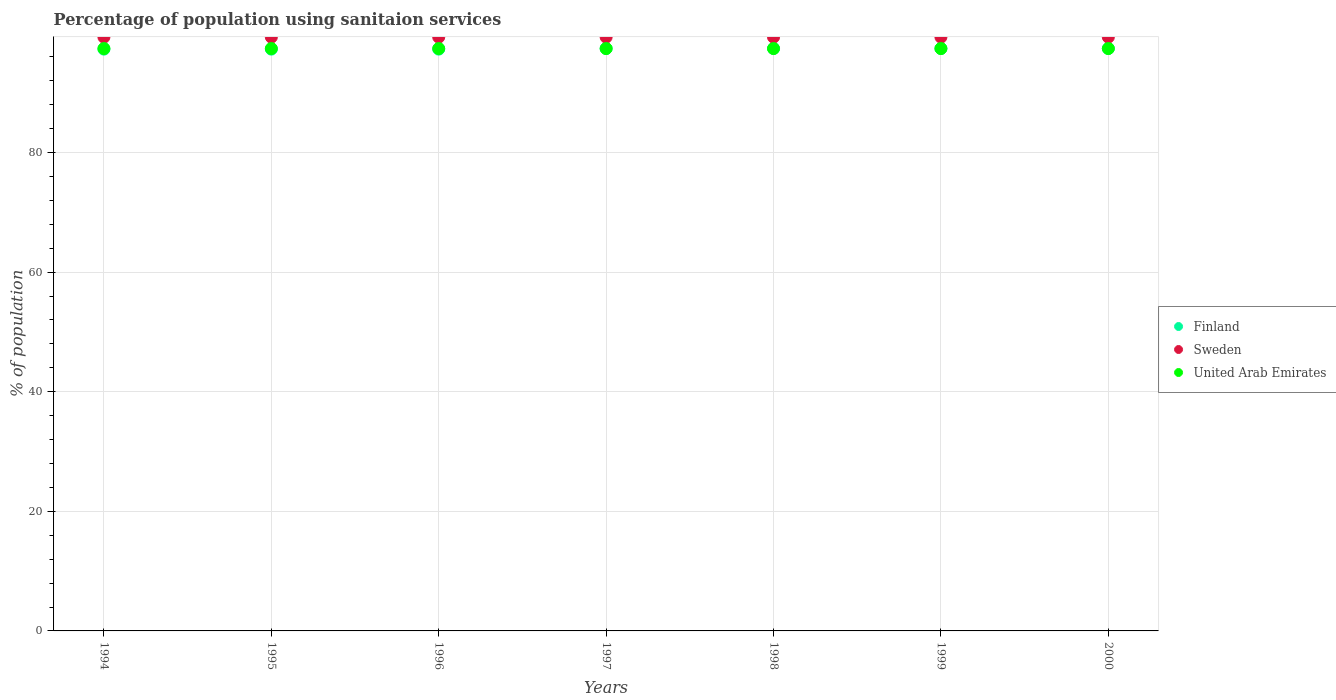Is the number of dotlines equal to the number of legend labels?
Ensure brevity in your answer.  Yes. What is the percentage of population using sanitaion services in Sweden in 1994?
Offer a very short reply. 99.3. Across all years, what is the maximum percentage of population using sanitaion services in United Arab Emirates?
Make the answer very short. 97.4. Across all years, what is the minimum percentage of population using sanitaion services in Finland?
Your response must be concise. 97.3. In which year was the percentage of population using sanitaion services in Sweden maximum?
Your answer should be very brief. 1994. In which year was the percentage of population using sanitaion services in Finland minimum?
Provide a short and direct response. 1994. What is the total percentage of population using sanitaion services in Sweden in the graph?
Your answer should be compact. 695.1. What is the difference between the percentage of population using sanitaion services in United Arab Emirates in 1995 and that in 1999?
Your answer should be compact. 0. What is the difference between the percentage of population using sanitaion services in Sweden in 1995 and the percentage of population using sanitaion services in United Arab Emirates in 1997?
Provide a short and direct response. 1.9. What is the average percentage of population using sanitaion services in United Arab Emirates per year?
Your response must be concise. 97.4. In the year 1997, what is the difference between the percentage of population using sanitaion services in Finland and percentage of population using sanitaion services in Sweden?
Keep it short and to the point. -1.9. In how many years, is the percentage of population using sanitaion services in Finland greater than 32 %?
Your answer should be compact. 7. What is the difference between the highest and the lowest percentage of population using sanitaion services in United Arab Emirates?
Make the answer very short. 0. Is it the case that in every year, the sum of the percentage of population using sanitaion services in Finland and percentage of population using sanitaion services in Sweden  is greater than the percentage of population using sanitaion services in United Arab Emirates?
Provide a succinct answer. Yes. Does the percentage of population using sanitaion services in Finland monotonically increase over the years?
Make the answer very short. No. Is the percentage of population using sanitaion services in Sweden strictly less than the percentage of population using sanitaion services in Finland over the years?
Offer a terse response. No. How many dotlines are there?
Offer a terse response. 3. How many years are there in the graph?
Your answer should be compact. 7. What is the difference between two consecutive major ticks on the Y-axis?
Ensure brevity in your answer.  20. Does the graph contain any zero values?
Give a very brief answer. No. Does the graph contain grids?
Your answer should be very brief. Yes. How are the legend labels stacked?
Provide a succinct answer. Vertical. What is the title of the graph?
Your answer should be very brief. Percentage of population using sanitaion services. Does "Seychelles" appear as one of the legend labels in the graph?
Ensure brevity in your answer.  No. What is the label or title of the X-axis?
Your answer should be compact. Years. What is the label or title of the Y-axis?
Make the answer very short. % of population. What is the % of population of Finland in 1994?
Offer a very short reply. 97.3. What is the % of population of Sweden in 1994?
Provide a succinct answer. 99.3. What is the % of population of United Arab Emirates in 1994?
Your response must be concise. 97.4. What is the % of population in Finland in 1995?
Provide a short and direct response. 97.3. What is the % of population of Sweden in 1995?
Give a very brief answer. 99.3. What is the % of population of United Arab Emirates in 1995?
Provide a short and direct response. 97.4. What is the % of population in Finland in 1996?
Make the answer very short. 97.3. What is the % of population of Sweden in 1996?
Provide a short and direct response. 99.3. What is the % of population of United Arab Emirates in 1996?
Your response must be concise. 97.4. What is the % of population of Finland in 1997?
Keep it short and to the point. 97.4. What is the % of population of Sweden in 1997?
Provide a short and direct response. 99.3. What is the % of population in United Arab Emirates in 1997?
Your answer should be very brief. 97.4. What is the % of population of Finland in 1998?
Provide a short and direct response. 97.4. What is the % of population of Sweden in 1998?
Ensure brevity in your answer.  99.3. What is the % of population of United Arab Emirates in 1998?
Your answer should be compact. 97.4. What is the % of population in Finland in 1999?
Give a very brief answer. 97.4. What is the % of population of Sweden in 1999?
Make the answer very short. 99.3. What is the % of population of United Arab Emirates in 1999?
Provide a succinct answer. 97.4. What is the % of population in Finland in 2000?
Ensure brevity in your answer.  97.4. What is the % of population of Sweden in 2000?
Keep it short and to the point. 99.3. What is the % of population of United Arab Emirates in 2000?
Your answer should be compact. 97.4. Across all years, what is the maximum % of population in Finland?
Your response must be concise. 97.4. Across all years, what is the maximum % of population in Sweden?
Offer a very short reply. 99.3. Across all years, what is the maximum % of population in United Arab Emirates?
Provide a succinct answer. 97.4. Across all years, what is the minimum % of population of Finland?
Your answer should be compact. 97.3. Across all years, what is the minimum % of population of Sweden?
Ensure brevity in your answer.  99.3. Across all years, what is the minimum % of population in United Arab Emirates?
Offer a very short reply. 97.4. What is the total % of population of Finland in the graph?
Give a very brief answer. 681.5. What is the total % of population in Sweden in the graph?
Your answer should be compact. 695.1. What is the total % of population in United Arab Emirates in the graph?
Your answer should be very brief. 681.8. What is the difference between the % of population of Sweden in 1994 and that in 1995?
Keep it short and to the point. 0. What is the difference between the % of population of Finland in 1994 and that in 1996?
Offer a terse response. 0. What is the difference between the % of population in United Arab Emirates in 1994 and that in 1996?
Make the answer very short. 0. What is the difference between the % of population of Sweden in 1994 and that in 1997?
Ensure brevity in your answer.  0. What is the difference between the % of population of United Arab Emirates in 1994 and that in 1997?
Your answer should be very brief. 0. What is the difference between the % of population of Finland in 1994 and that in 1998?
Offer a terse response. -0.1. What is the difference between the % of population in United Arab Emirates in 1994 and that in 1998?
Your answer should be compact. 0. What is the difference between the % of population of Finland in 1994 and that in 1999?
Provide a succinct answer. -0.1. What is the difference between the % of population in Sweden in 1994 and that in 1999?
Offer a very short reply. 0. What is the difference between the % of population of United Arab Emirates in 1994 and that in 1999?
Provide a short and direct response. 0. What is the difference between the % of population of Finland in 1994 and that in 2000?
Provide a short and direct response. -0.1. What is the difference between the % of population of Finland in 1995 and that in 1996?
Make the answer very short. 0. What is the difference between the % of population of United Arab Emirates in 1995 and that in 1996?
Ensure brevity in your answer.  0. What is the difference between the % of population in Finland in 1995 and that in 1997?
Offer a very short reply. -0.1. What is the difference between the % of population of Sweden in 1995 and that in 1998?
Provide a succinct answer. 0. What is the difference between the % of population of Sweden in 1995 and that in 1999?
Give a very brief answer. 0. What is the difference between the % of population of Finland in 1995 and that in 2000?
Your answer should be very brief. -0.1. What is the difference between the % of population of Sweden in 1995 and that in 2000?
Provide a short and direct response. 0. What is the difference between the % of population of United Arab Emirates in 1995 and that in 2000?
Keep it short and to the point. 0. What is the difference between the % of population of United Arab Emirates in 1996 and that in 1997?
Provide a short and direct response. 0. What is the difference between the % of population in Finland in 1996 and that in 1999?
Ensure brevity in your answer.  -0.1. What is the difference between the % of population of Finland in 1997 and that in 1998?
Your answer should be compact. 0. What is the difference between the % of population of Sweden in 1997 and that in 1998?
Your response must be concise. 0. What is the difference between the % of population of United Arab Emirates in 1997 and that in 1998?
Your answer should be very brief. 0. What is the difference between the % of population of Sweden in 1997 and that in 1999?
Make the answer very short. 0. What is the difference between the % of population in United Arab Emirates in 1997 and that in 1999?
Provide a succinct answer. 0. What is the difference between the % of population of Sweden in 1997 and that in 2000?
Your answer should be very brief. 0. What is the difference between the % of population in Finland in 1998 and that in 1999?
Provide a succinct answer. 0. What is the difference between the % of population of Sweden in 1998 and that in 1999?
Provide a short and direct response. 0. What is the difference between the % of population of United Arab Emirates in 1998 and that in 1999?
Offer a terse response. 0. What is the difference between the % of population in Sweden in 1998 and that in 2000?
Ensure brevity in your answer.  0. What is the difference between the % of population in United Arab Emirates in 1998 and that in 2000?
Give a very brief answer. 0. What is the difference between the % of population in Sweden in 1999 and that in 2000?
Offer a very short reply. 0. What is the difference between the % of population in United Arab Emirates in 1999 and that in 2000?
Make the answer very short. 0. What is the difference between the % of population in Finland in 1994 and the % of population in Sweden in 1996?
Your answer should be compact. -2. What is the difference between the % of population of Finland in 1994 and the % of population of United Arab Emirates in 1997?
Make the answer very short. -0.1. What is the difference between the % of population in Finland in 1994 and the % of population in Sweden in 1998?
Your answer should be very brief. -2. What is the difference between the % of population in Finland in 1994 and the % of population in United Arab Emirates in 1998?
Keep it short and to the point. -0.1. What is the difference between the % of population of Sweden in 1994 and the % of population of United Arab Emirates in 1998?
Provide a short and direct response. 1.9. What is the difference between the % of population of Finland in 1994 and the % of population of United Arab Emirates in 1999?
Give a very brief answer. -0.1. What is the difference between the % of population of Finland in 1994 and the % of population of Sweden in 2000?
Keep it short and to the point. -2. What is the difference between the % of population of Finland in 1994 and the % of population of United Arab Emirates in 2000?
Offer a terse response. -0.1. What is the difference between the % of population of Finland in 1995 and the % of population of United Arab Emirates in 1996?
Make the answer very short. -0.1. What is the difference between the % of population of Finland in 1995 and the % of population of United Arab Emirates in 1997?
Offer a very short reply. -0.1. What is the difference between the % of population of Finland in 1995 and the % of population of United Arab Emirates in 1998?
Your answer should be very brief. -0.1. What is the difference between the % of population in Sweden in 1995 and the % of population in United Arab Emirates in 1998?
Offer a terse response. 1.9. What is the difference between the % of population in Sweden in 1995 and the % of population in United Arab Emirates in 1999?
Provide a succinct answer. 1.9. What is the difference between the % of population in Finland in 1996 and the % of population in Sweden in 1997?
Your response must be concise. -2. What is the difference between the % of population in Finland in 1996 and the % of population in United Arab Emirates in 1997?
Keep it short and to the point. -0.1. What is the difference between the % of population of Finland in 1996 and the % of population of Sweden in 1998?
Your answer should be very brief. -2. What is the difference between the % of population of Finland in 1996 and the % of population of United Arab Emirates in 1998?
Keep it short and to the point. -0.1. What is the difference between the % of population of Sweden in 1996 and the % of population of United Arab Emirates in 1998?
Provide a short and direct response. 1.9. What is the difference between the % of population in Finland in 1997 and the % of population in United Arab Emirates in 1998?
Your answer should be very brief. 0. What is the difference between the % of population in Sweden in 1997 and the % of population in United Arab Emirates in 1999?
Offer a terse response. 1.9. What is the difference between the % of population of Finland in 1997 and the % of population of Sweden in 2000?
Make the answer very short. -1.9. What is the difference between the % of population of Finland in 1997 and the % of population of United Arab Emirates in 2000?
Your answer should be very brief. 0. What is the difference between the % of population of Finland in 1998 and the % of population of Sweden in 1999?
Offer a terse response. -1.9. What is the difference between the % of population of Finland in 1998 and the % of population of United Arab Emirates in 2000?
Your answer should be very brief. 0. What is the difference between the % of population in Finland in 1999 and the % of population in Sweden in 2000?
Offer a terse response. -1.9. What is the difference between the % of population in Finland in 1999 and the % of population in United Arab Emirates in 2000?
Your answer should be very brief. 0. What is the difference between the % of population in Sweden in 1999 and the % of population in United Arab Emirates in 2000?
Your answer should be compact. 1.9. What is the average % of population in Finland per year?
Make the answer very short. 97.36. What is the average % of population in Sweden per year?
Offer a terse response. 99.3. What is the average % of population in United Arab Emirates per year?
Your answer should be compact. 97.4. In the year 1995, what is the difference between the % of population in Finland and % of population in United Arab Emirates?
Your answer should be very brief. -0.1. In the year 1995, what is the difference between the % of population in Sweden and % of population in United Arab Emirates?
Offer a very short reply. 1.9. In the year 1999, what is the difference between the % of population of Finland and % of population of Sweden?
Provide a short and direct response. -1.9. In the year 1999, what is the difference between the % of population in Finland and % of population in United Arab Emirates?
Your answer should be compact. 0. In the year 1999, what is the difference between the % of population in Sweden and % of population in United Arab Emirates?
Your answer should be very brief. 1.9. In the year 2000, what is the difference between the % of population of Finland and % of population of United Arab Emirates?
Give a very brief answer. 0. In the year 2000, what is the difference between the % of population of Sweden and % of population of United Arab Emirates?
Give a very brief answer. 1.9. What is the ratio of the % of population in Sweden in 1994 to that in 1995?
Keep it short and to the point. 1. What is the ratio of the % of population of Finland in 1994 to that in 1996?
Offer a very short reply. 1. What is the ratio of the % of population of United Arab Emirates in 1994 to that in 1996?
Offer a terse response. 1. What is the ratio of the % of population in Finland in 1994 to that in 1997?
Provide a short and direct response. 1. What is the ratio of the % of population in Sweden in 1994 to that in 1997?
Offer a very short reply. 1. What is the ratio of the % of population of United Arab Emirates in 1994 to that in 1997?
Your response must be concise. 1. What is the ratio of the % of population in Sweden in 1994 to that in 1998?
Provide a short and direct response. 1. What is the ratio of the % of population in United Arab Emirates in 1994 to that in 1998?
Offer a terse response. 1. What is the ratio of the % of population of Finland in 1994 to that in 1999?
Provide a succinct answer. 1. What is the ratio of the % of population of Sweden in 1994 to that in 1999?
Ensure brevity in your answer.  1. What is the ratio of the % of population of Sweden in 1994 to that in 2000?
Provide a succinct answer. 1. What is the ratio of the % of population of Finland in 1995 to that in 1996?
Offer a terse response. 1. What is the ratio of the % of population in Finland in 1995 to that in 1997?
Ensure brevity in your answer.  1. What is the ratio of the % of population of Sweden in 1995 to that in 1997?
Offer a very short reply. 1. What is the ratio of the % of population of United Arab Emirates in 1995 to that in 1997?
Your response must be concise. 1. What is the ratio of the % of population of Finland in 1995 to that in 1998?
Offer a very short reply. 1. What is the ratio of the % of population of Sweden in 1995 to that in 1998?
Ensure brevity in your answer.  1. What is the ratio of the % of population in United Arab Emirates in 1995 to that in 1998?
Your answer should be compact. 1. What is the ratio of the % of population in Sweden in 1995 to that in 1999?
Your answer should be very brief. 1. What is the ratio of the % of population of Finland in 1995 to that in 2000?
Offer a very short reply. 1. What is the ratio of the % of population of Sweden in 1995 to that in 2000?
Give a very brief answer. 1. What is the ratio of the % of population of Finland in 1996 to that in 1997?
Your answer should be compact. 1. What is the ratio of the % of population of Finland in 1996 to that in 1999?
Your answer should be compact. 1. What is the ratio of the % of population of Sweden in 1996 to that in 1999?
Ensure brevity in your answer.  1. What is the ratio of the % of population of United Arab Emirates in 1996 to that in 1999?
Ensure brevity in your answer.  1. What is the ratio of the % of population in United Arab Emirates in 1996 to that in 2000?
Keep it short and to the point. 1. What is the ratio of the % of population of Finland in 1997 to that in 1998?
Make the answer very short. 1. What is the ratio of the % of population of Sweden in 1997 to that in 1998?
Make the answer very short. 1. What is the ratio of the % of population in United Arab Emirates in 1997 to that in 1998?
Give a very brief answer. 1. What is the ratio of the % of population in Sweden in 1997 to that in 1999?
Keep it short and to the point. 1. What is the ratio of the % of population in United Arab Emirates in 1997 to that in 1999?
Your answer should be compact. 1. What is the ratio of the % of population in Finland in 1998 to that in 1999?
Make the answer very short. 1. What is the ratio of the % of population of Sweden in 1998 to that in 1999?
Keep it short and to the point. 1. What is the ratio of the % of population of Finland in 1998 to that in 2000?
Your answer should be very brief. 1. What is the ratio of the % of population of United Arab Emirates in 1998 to that in 2000?
Offer a terse response. 1. What is the ratio of the % of population in Sweden in 1999 to that in 2000?
Provide a short and direct response. 1. What is the difference between the highest and the second highest % of population in Sweden?
Your answer should be very brief. 0. What is the difference between the highest and the lowest % of population of Finland?
Your answer should be compact. 0.1. 